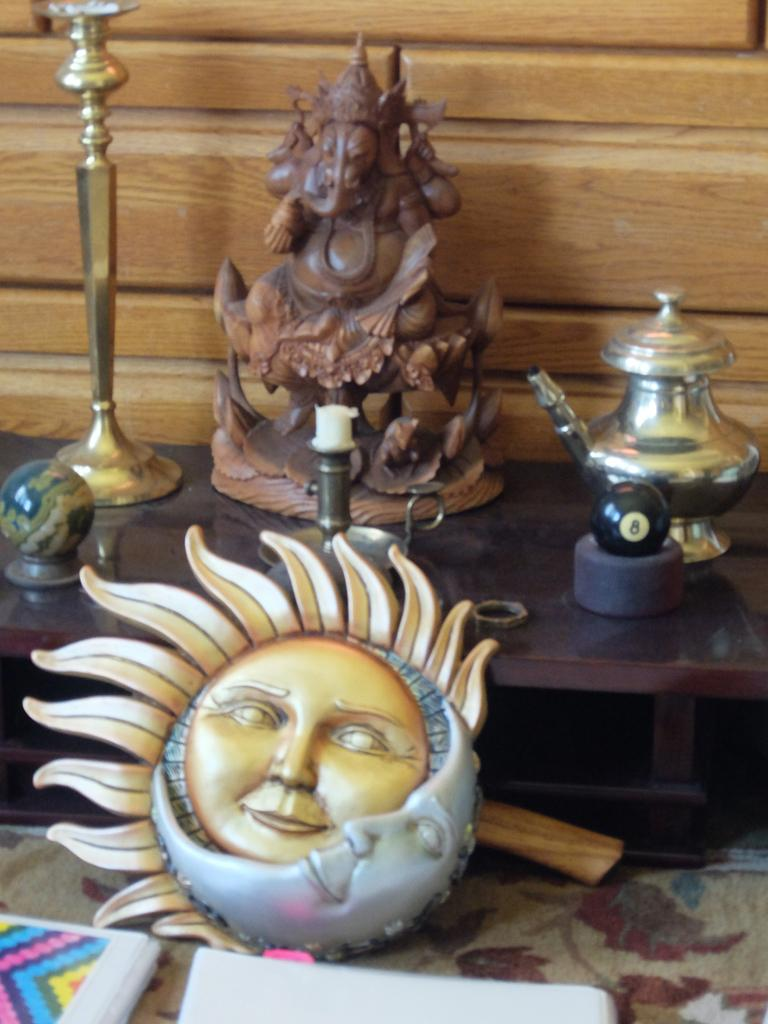What is the main subject in the image? There is an idol in the image. What other objects can be seen in the image? There is a globe, a ball, metal objects on a table, objects on a mat, and a wooden object in the background. Can you describe the wooden object in the background? There is a wooden object in the background of the image, but its specific characteristics are not mentioned in the provided facts. Where are the metal objects located in the image? The metal objects are on a table in the image. How many books can be seen in the image? There is no mention of any books in the provided facts, so it cannot be determined from the image. Can you tell me what type of teeth the cats have in the image? There are no cats present in the image, so it cannot be determined from the image. 